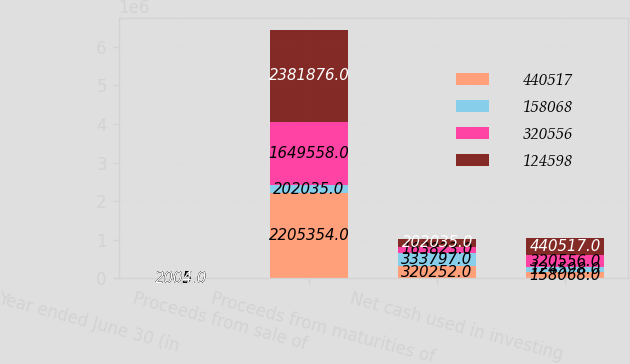Convert chart to OTSL. <chart><loc_0><loc_0><loc_500><loc_500><stacked_bar_chart><ecel><fcel>Year ended June 30 (in<fcel>Proceeds from sale of<fcel>Proceeds from maturities of<fcel>Net cash used in investing<nl><fcel>440517<fcel>2005<fcel>2.20535e+06<fcel>320252<fcel>158068<nl><fcel>158068<fcel>2005<fcel>202035<fcel>333797<fcel>124598<nl><fcel>320556<fcel>2004<fcel>1.64956e+06<fcel>163823<fcel>320556<nl><fcel>124598<fcel>2004<fcel>2.38188e+06<fcel>202035<fcel>440517<nl></chart> 